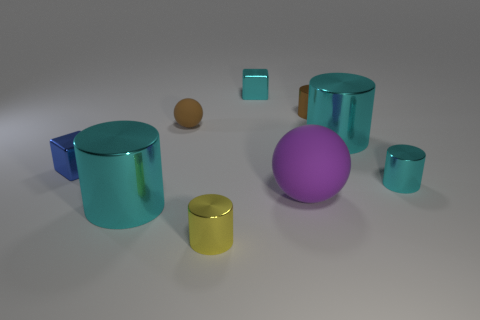What is the ball behind the large cyan thing that is to the right of the big cyan object that is on the left side of the purple rubber ball made of?
Provide a succinct answer. Rubber. Is the yellow thing the same shape as the brown metal object?
Your answer should be very brief. Yes. What number of small cylinders are behind the tiny brown rubber thing and in front of the small matte thing?
Your answer should be compact. 0. The metallic object in front of the big cyan shiny cylinder to the left of the yellow metallic cylinder is what color?
Offer a terse response. Yellow. Are there the same number of tiny blue metallic cubes to the left of the blue cube and purple matte blocks?
Give a very brief answer. Yes. What number of shiny things are to the left of the large cyan cylinder that is left of the block to the right of the blue object?
Provide a succinct answer. 1. What is the color of the cube that is to the right of the tiny yellow metallic cylinder?
Your answer should be very brief. Cyan. There is a object that is to the right of the tiny cyan block and in front of the small cyan metallic cylinder; what is it made of?
Provide a succinct answer. Rubber. What number of tiny metallic objects are in front of the tiny metallic block that is in front of the brown metallic thing?
Your answer should be very brief. 2. The small yellow thing has what shape?
Ensure brevity in your answer.  Cylinder. 